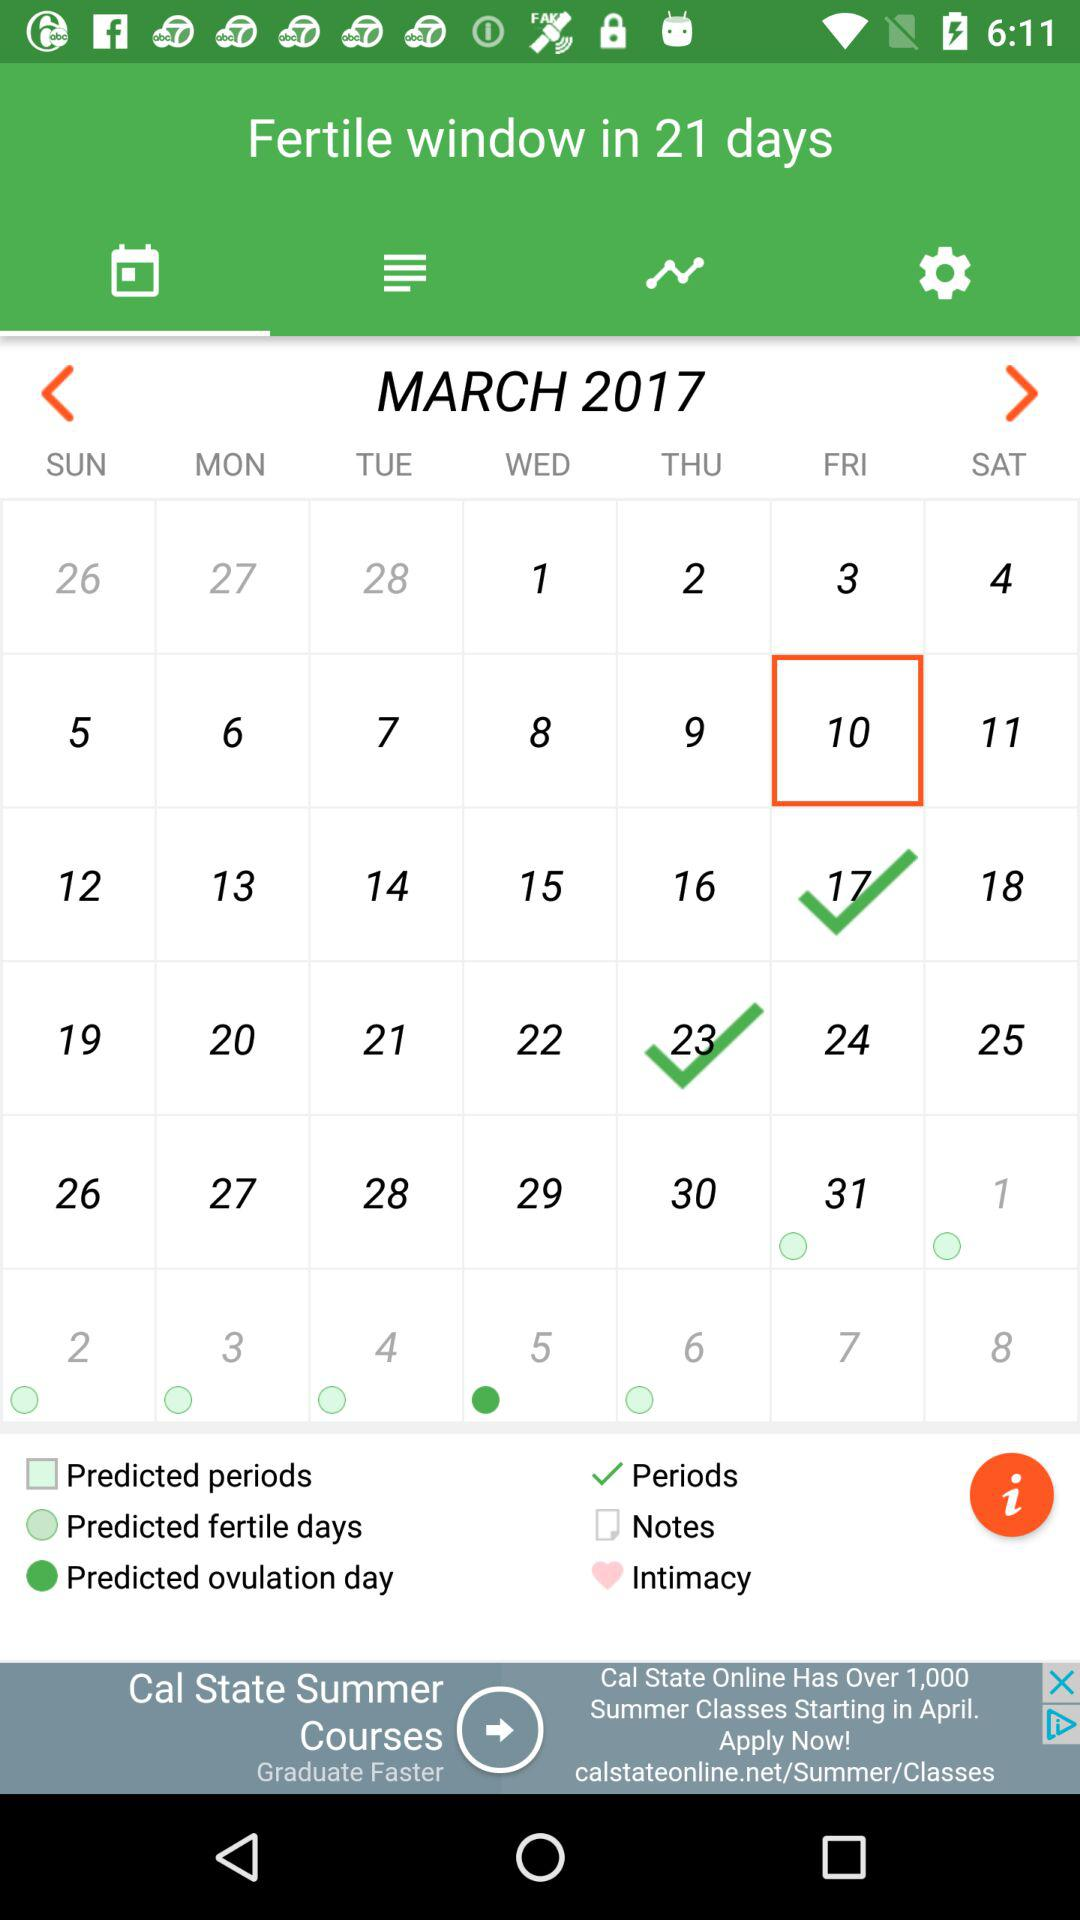In how many days will the fertile window begin? The fertile window will begin in 21 days. 